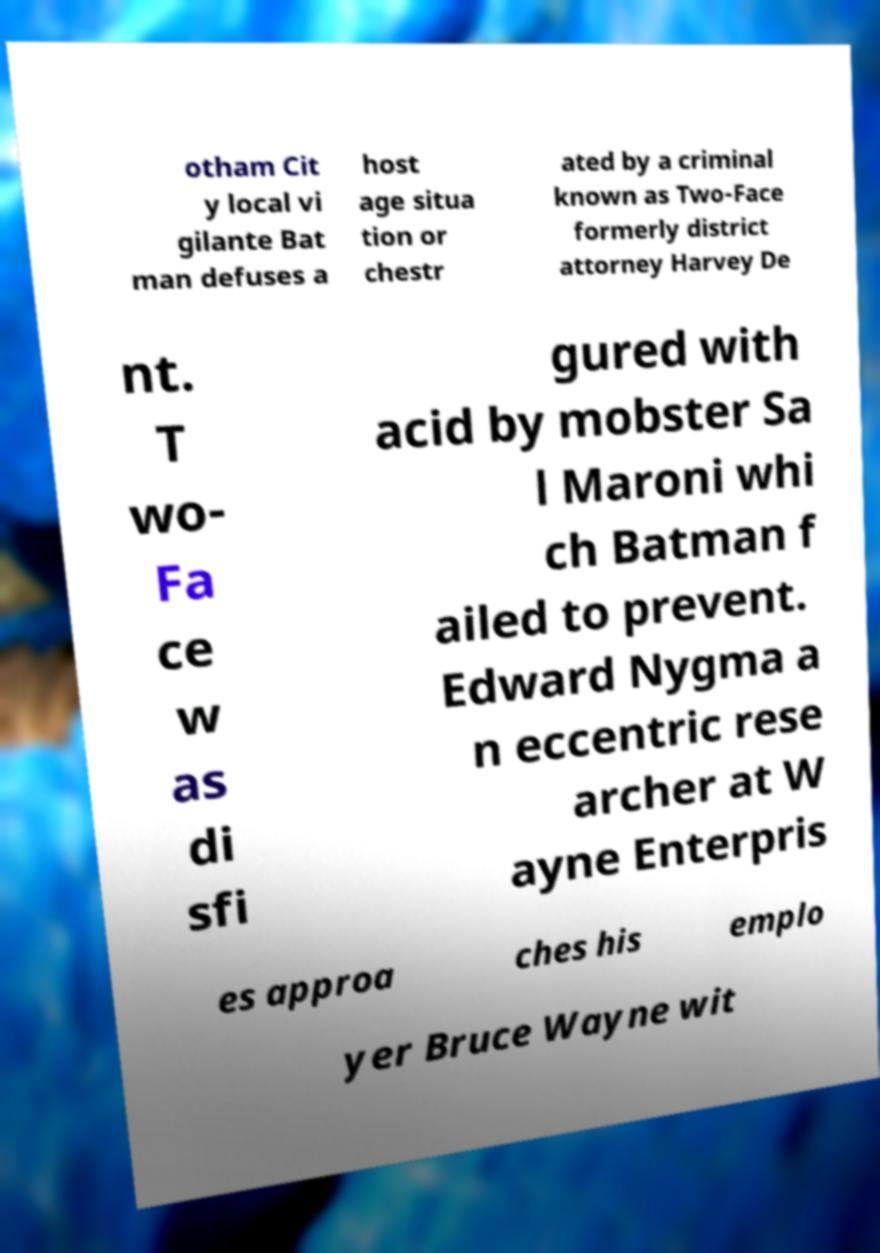Could you extract and type out the text from this image? otham Cit y local vi gilante Bat man defuses a host age situa tion or chestr ated by a criminal known as Two-Face formerly district attorney Harvey De nt. T wo- Fa ce w as di sfi gured with acid by mobster Sa l Maroni whi ch Batman f ailed to prevent. Edward Nygma a n eccentric rese archer at W ayne Enterpris es approa ches his emplo yer Bruce Wayne wit 